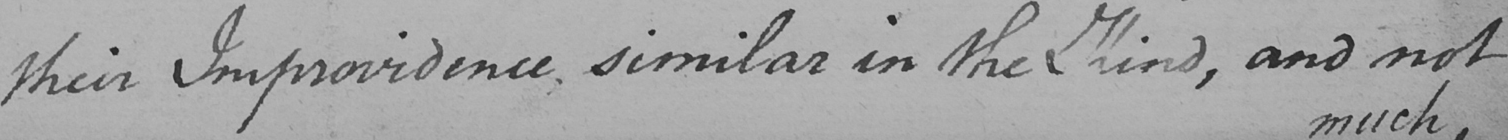Can you read and transcribe this handwriting? their Improvidence , similar in the Kind , and not 